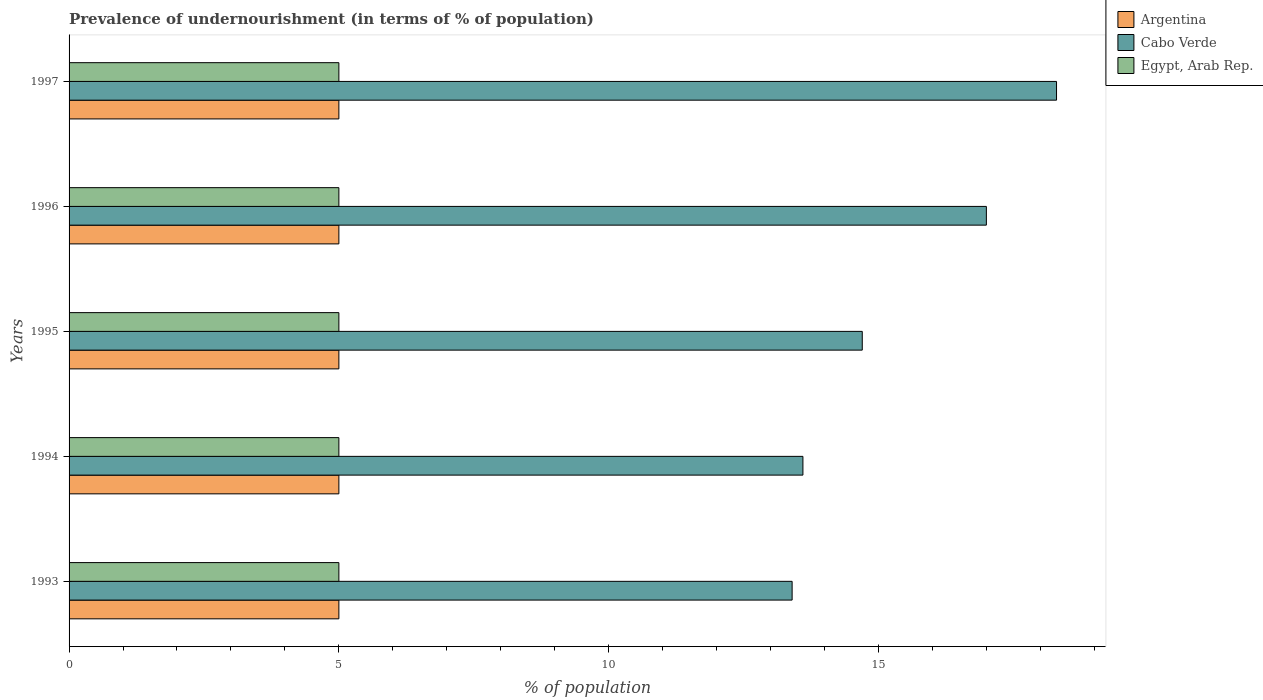Are the number of bars per tick equal to the number of legend labels?
Your answer should be very brief. Yes. What is the percentage of undernourished population in Egypt, Arab Rep. in 1994?
Offer a terse response. 5. Across all years, what is the maximum percentage of undernourished population in Cabo Verde?
Offer a terse response. 18.3. Across all years, what is the minimum percentage of undernourished population in Egypt, Arab Rep.?
Keep it short and to the point. 5. In which year was the percentage of undernourished population in Egypt, Arab Rep. minimum?
Keep it short and to the point. 1993. What is the total percentage of undernourished population in Cabo Verde in the graph?
Keep it short and to the point. 77. What is the average percentage of undernourished population in Egypt, Arab Rep. per year?
Offer a terse response. 5. What is the ratio of the percentage of undernourished population in Egypt, Arab Rep. in 1994 to that in 1996?
Your answer should be compact. 1. Is the percentage of undernourished population in Argentina in 1994 less than that in 1995?
Your answer should be very brief. No. Is the difference between the percentage of undernourished population in Cabo Verde in 1994 and 1995 greater than the difference between the percentage of undernourished population in Argentina in 1994 and 1995?
Give a very brief answer. No. What is the difference between the highest and the second highest percentage of undernourished population in Cabo Verde?
Your answer should be compact. 1.3. What does the 2nd bar from the top in 1994 represents?
Your answer should be compact. Cabo Verde. How many bars are there?
Keep it short and to the point. 15. Are all the bars in the graph horizontal?
Offer a very short reply. Yes. What is the difference between two consecutive major ticks on the X-axis?
Your answer should be compact. 5. Does the graph contain any zero values?
Offer a terse response. No. How many legend labels are there?
Keep it short and to the point. 3. What is the title of the graph?
Give a very brief answer. Prevalence of undernourishment (in terms of % of population). What is the label or title of the X-axis?
Give a very brief answer. % of population. What is the label or title of the Y-axis?
Keep it short and to the point. Years. What is the % of population in Argentina in 1993?
Offer a very short reply. 5. What is the % of population in Cabo Verde in 1993?
Provide a short and direct response. 13.4. What is the % of population in Egypt, Arab Rep. in 1995?
Your response must be concise. 5. What is the % of population of Cabo Verde in 1996?
Provide a succinct answer. 17. What is the % of population of Cabo Verde in 1997?
Offer a terse response. 18.3. Across all years, what is the maximum % of population of Argentina?
Ensure brevity in your answer.  5. Across all years, what is the maximum % of population of Egypt, Arab Rep.?
Offer a terse response. 5. Across all years, what is the minimum % of population in Argentina?
Make the answer very short. 5. Across all years, what is the minimum % of population in Cabo Verde?
Provide a short and direct response. 13.4. What is the total % of population in Cabo Verde in the graph?
Keep it short and to the point. 77. What is the total % of population of Egypt, Arab Rep. in the graph?
Keep it short and to the point. 25. What is the difference between the % of population of Argentina in 1993 and that in 1994?
Give a very brief answer. 0. What is the difference between the % of population in Egypt, Arab Rep. in 1993 and that in 1994?
Your answer should be very brief. 0. What is the difference between the % of population in Cabo Verde in 1993 and that in 1995?
Provide a short and direct response. -1.3. What is the difference between the % of population in Egypt, Arab Rep. in 1993 and that in 1995?
Provide a short and direct response. 0. What is the difference between the % of population in Argentina in 1993 and that in 1997?
Offer a very short reply. 0. What is the difference between the % of population in Egypt, Arab Rep. in 1993 and that in 1997?
Provide a succinct answer. 0. What is the difference between the % of population in Argentina in 1994 and that in 1995?
Offer a terse response. 0. What is the difference between the % of population in Cabo Verde in 1994 and that in 1996?
Provide a short and direct response. -3.4. What is the difference between the % of population of Egypt, Arab Rep. in 1994 and that in 1996?
Give a very brief answer. 0. What is the difference between the % of population of Egypt, Arab Rep. in 1994 and that in 1997?
Keep it short and to the point. 0. What is the difference between the % of population in Cabo Verde in 1995 and that in 1996?
Provide a succinct answer. -2.3. What is the difference between the % of population in Egypt, Arab Rep. in 1995 and that in 1996?
Provide a succinct answer. 0. What is the difference between the % of population of Argentina in 1995 and that in 1997?
Your answer should be very brief. 0. What is the difference between the % of population in Cabo Verde in 1995 and that in 1997?
Offer a very short reply. -3.6. What is the difference between the % of population in Egypt, Arab Rep. in 1996 and that in 1997?
Your response must be concise. 0. What is the difference between the % of population of Argentina in 1993 and the % of population of Cabo Verde in 1994?
Ensure brevity in your answer.  -8.6. What is the difference between the % of population in Argentina in 1993 and the % of population in Egypt, Arab Rep. in 1994?
Make the answer very short. 0. What is the difference between the % of population of Argentina in 1993 and the % of population of Egypt, Arab Rep. in 1995?
Keep it short and to the point. 0. What is the difference between the % of population of Argentina in 1993 and the % of population of Cabo Verde in 1996?
Provide a succinct answer. -12. What is the difference between the % of population in Argentina in 1993 and the % of population in Egypt, Arab Rep. in 1997?
Ensure brevity in your answer.  0. What is the difference between the % of population in Argentina in 1994 and the % of population in Egypt, Arab Rep. in 1995?
Keep it short and to the point. 0. What is the difference between the % of population of Cabo Verde in 1994 and the % of population of Egypt, Arab Rep. in 1996?
Provide a succinct answer. 8.6. What is the difference between the % of population in Argentina in 1994 and the % of population in Cabo Verde in 1997?
Provide a succinct answer. -13.3. What is the difference between the % of population in Argentina in 1994 and the % of population in Egypt, Arab Rep. in 1997?
Offer a very short reply. 0. What is the difference between the % of population of Cabo Verde in 1994 and the % of population of Egypt, Arab Rep. in 1997?
Provide a succinct answer. 8.6. What is the difference between the % of population of Argentina in 1995 and the % of population of Cabo Verde in 1996?
Your answer should be compact. -12. What is the difference between the % of population in Argentina in 1995 and the % of population in Egypt, Arab Rep. in 1996?
Offer a terse response. 0. What is the difference between the % of population in Argentina in 1995 and the % of population in Cabo Verde in 1997?
Your response must be concise. -13.3. What is the difference between the % of population of Argentina in 1995 and the % of population of Egypt, Arab Rep. in 1997?
Offer a terse response. 0. What is the difference between the % of population in Cabo Verde in 1995 and the % of population in Egypt, Arab Rep. in 1997?
Your answer should be compact. 9.7. What is the difference between the % of population of Argentina in 1996 and the % of population of Cabo Verde in 1997?
Give a very brief answer. -13.3. What is the difference between the % of population in Argentina in 1996 and the % of population in Egypt, Arab Rep. in 1997?
Keep it short and to the point. 0. What is the difference between the % of population of Cabo Verde in 1996 and the % of population of Egypt, Arab Rep. in 1997?
Keep it short and to the point. 12. What is the average % of population in Argentina per year?
Keep it short and to the point. 5. What is the average % of population of Egypt, Arab Rep. per year?
Ensure brevity in your answer.  5. In the year 1993, what is the difference between the % of population in Argentina and % of population in Cabo Verde?
Keep it short and to the point. -8.4. In the year 1994, what is the difference between the % of population of Argentina and % of population of Cabo Verde?
Ensure brevity in your answer.  -8.6. In the year 1994, what is the difference between the % of population of Cabo Verde and % of population of Egypt, Arab Rep.?
Ensure brevity in your answer.  8.6. In the year 1995, what is the difference between the % of population of Argentina and % of population of Cabo Verde?
Make the answer very short. -9.7. In the year 1995, what is the difference between the % of population of Argentina and % of population of Egypt, Arab Rep.?
Your answer should be compact. 0. In the year 1995, what is the difference between the % of population in Cabo Verde and % of population in Egypt, Arab Rep.?
Give a very brief answer. 9.7. In the year 1996, what is the difference between the % of population of Argentina and % of population of Egypt, Arab Rep.?
Ensure brevity in your answer.  0. In the year 1996, what is the difference between the % of population of Cabo Verde and % of population of Egypt, Arab Rep.?
Make the answer very short. 12. In the year 1997, what is the difference between the % of population of Argentina and % of population of Cabo Verde?
Give a very brief answer. -13.3. What is the ratio of the % of population in Egypt, Arab Rep. in 1993 to that in 1994?
Make the answer very short. 1. What is the ratio of the % of population of Cabo Verde in 1993 to that in 1995?
Provide a succinct answer. 0.91. What is the ratio of the % of population in Egypt, Arab Rep. in 1993 to that in 1995?
Your answer should be very brief. 1. What is the ratio of the % of population in Cabo Verde in 1993 to that in 1996?
Make the answer very short. 0.79. What is the ratio of the % of population in Egypt, Arab Rep. in 1993 to that in 1996?
Keep it short and to the point. 1. What is the ratio of the % of population in Argentina in 1993 to that in 1997?
Ensure brevity in your answer.  1. What is the ratio of the % of population in Cabo Verde in 1993 to that in 1997?
Your answer should be very brief. 0.73. What is the ratio of the % of population of Cabo Verde in 1994 to that in 1995?
Give a very brief answer. 0.93. What is the ratio of the % of population in Argentina in 1994 to that in 1996?
Make the answer very short. 1. What is the ratio of the % of population in Cabo Verde in 1994 to that in 1997?
Make the answer very short. 0.74. What is the ratio of the % of population in Egypt, Arab Rep. in 1994 to that in 1997?
Offer a terse response. 1. What is the ratio of the % of population in Cabo Verde in 1995 to that in 1996?
Make the answer very short. 0.86. What is the ratio of the % of population of Egypt, Arab Rep. in 1995 to that in 1996?
Offer a terse response. 1. What is the ratio of the % of population of Cabo Verde in 1995 to that in 1997?
Your response must be concise. 0.8. What is the ratio of the % of population in Cabo Verde in 1996 to that in 1997?
Your answer should be compact. 0.93. What is the ratio of the % of population in Egypt, Arab Rep. in 1996 to that in 1997?
Your response must be concise. 1. What is the difference between the highest and the second highest % of population of Cabo Verde?
Offer a very short reply. 1.3. What is the difference between the highest and the second highest % of population of Egypt, Arab Rep.?
Make the answer very short. 0. What is the difference between the highest and the lowest % of population in Argentina?
Give a very brief answer. 0. What is the difference between the highest and the lowest % of population of Cabo Verde?
Ensure brevity in your answer.  4.9. 